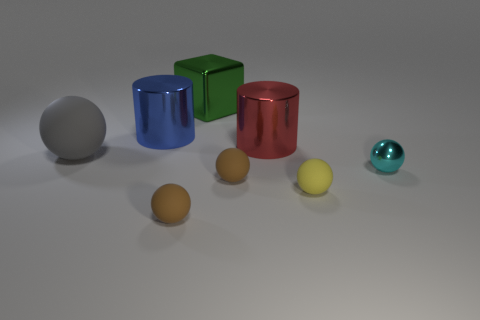What is the size of the metallic thing that is both in front of the blue metal cylinder and behind the large gray rubber thing?
Offer a terse response. Large. How many other objects are there of the same shape as the big gray object?
Offer a terse response. 4. What number of cylinders are either big gray objects or green metal objects?
Give a very brief answer. 0. There is a large shiny cylinder in front of the shiny cylinder that is to the left of the red metal cylinder; is there a big metallic cylinder in front of it?
Provide a succinct answer. No. What is the color of the metallic object that is the same shape as the gray rubber object?
Make the answer very short. Cyan. How many blue things are tiny matte blocks or tiny rubber things?
Ensure brevity in your answer.  0. What is the material of the brown sphere that is in front of the small rubber thing right of the big red object?
Your response must be concise. Rubber. Does the red metal object have the same shape as the tiny cyan shiny object?
Your response must be concise. No. What is the color of the other shiny cylinder that is the same size as the blue cylinder?
Make the answer very short. Red. Is there a metallic thing of the same color as the big sphere?
Offer a very short reply. No. 